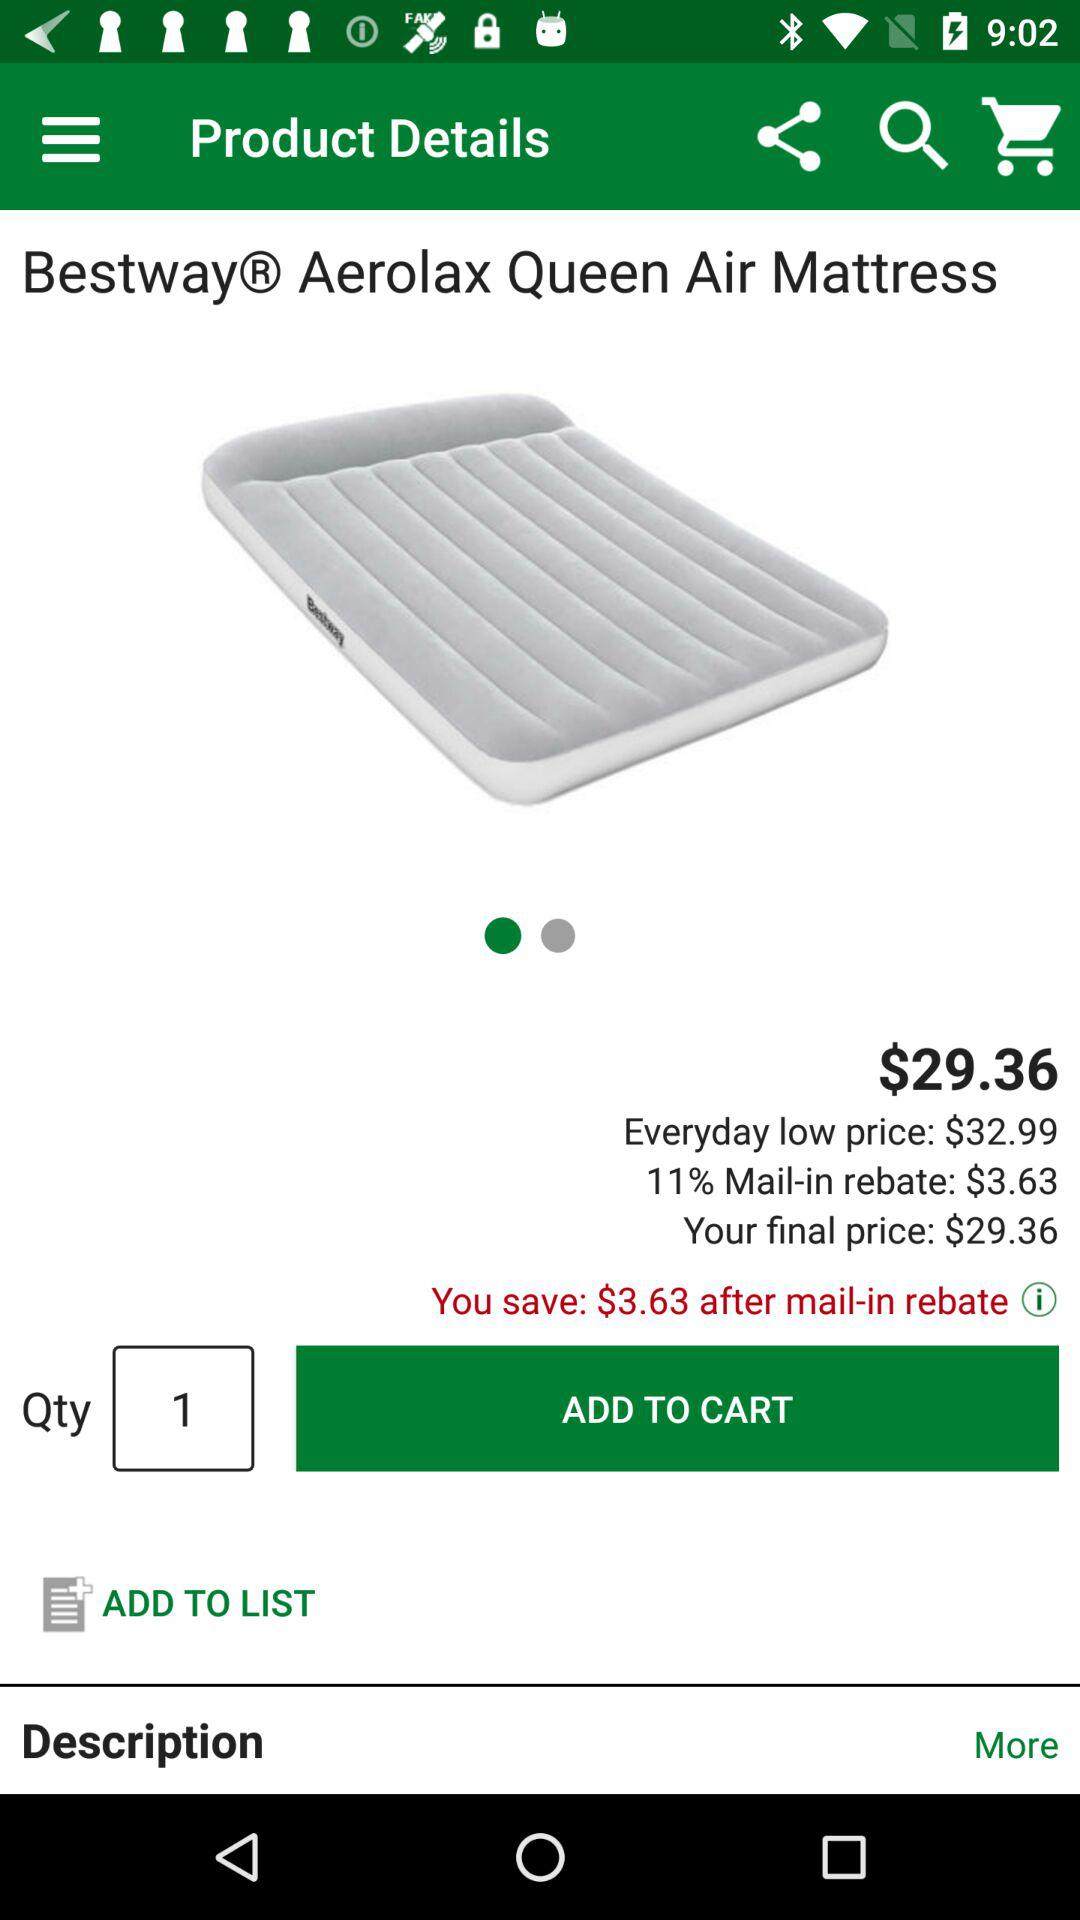What is the quantity shown there? The shown quantity is 1. 